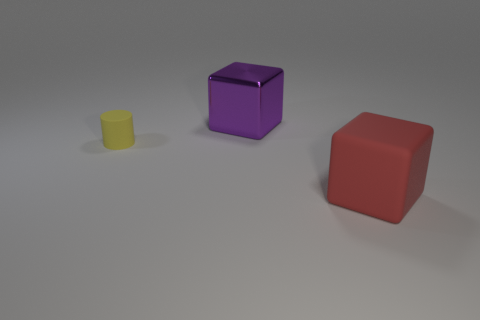Is there anything else that has the same material as the purple thing?
Give a very brief answer. No. Is there a large cube that is behind the matte object that is behind the red thing?
Ensure brevity in your answer.  Yes. The red object is what size?
Ensure brevity in your answer.  Large. How many things are either large objects or green metal cylinders?
Offer a very short reply. 2. Does the cube in front of the yellow rubber cylinder have the same material as the object that is to the left of the purple metal object?
Keep it short and to the point. Yes. There is a big object that is made of the same material as the small yellow thing; what is its color?
Give a very brief answer. Red. What number of other blocks are the same size as the red rubber cube?
Give a very brief answer. 1. What number of other things are there of the same color as the large shiny object?
Your answer should be compact. 0. Is there any other thing that is the same size as the red cube?
Provide a succinct answer. Yes. Does the rubber object that is in front of the tiny rubber object have the same shape as the matte thing that is to the left of the rubber block?
Offer a very short reply. No. 